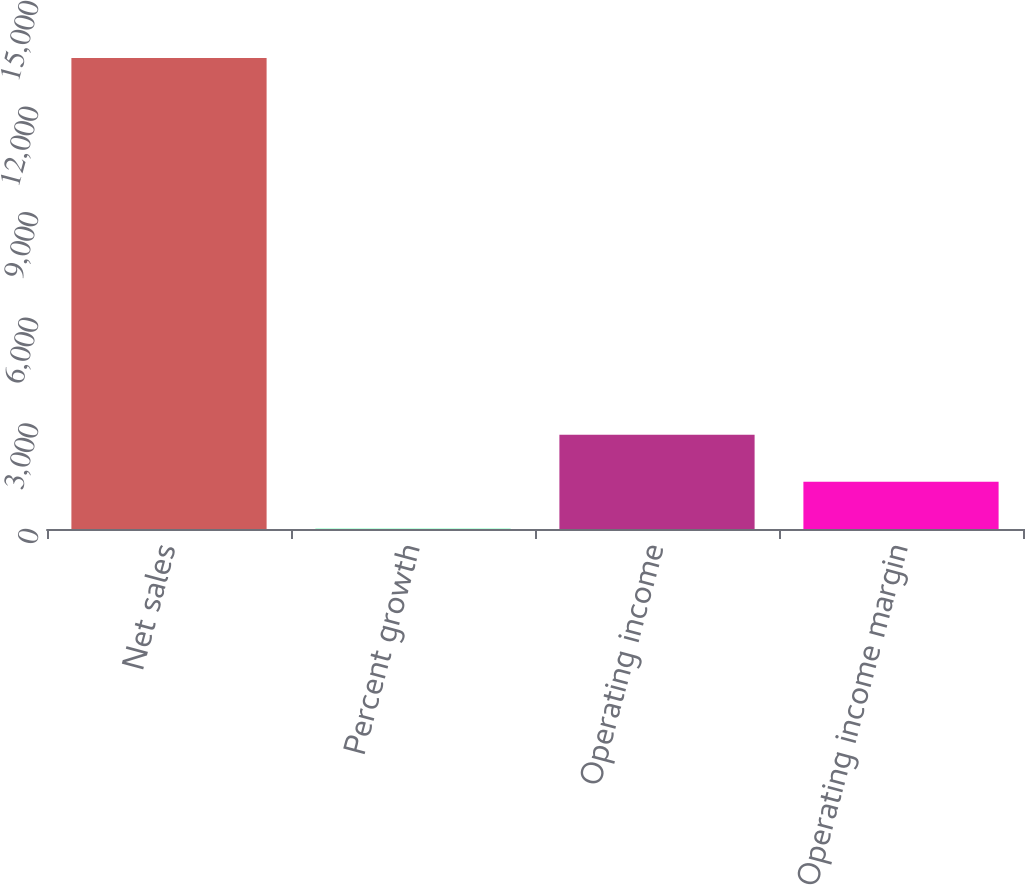Convert chart to OTSL. <chart><loc_0><loc_0><loc_500><loc_500><bar_chart><fcel>Net sales<fcel>Percent growth<fcel>Operating income<fcel>Operating income margin<nl><fcel>13378<fcel>4.4<fcel>2679.12<fcel>1341.76<nl></chart> 